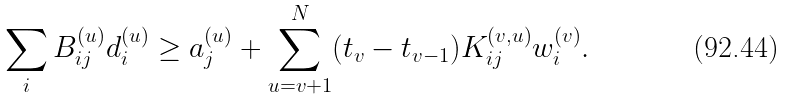<formula> <loc_0><loc_0><loc_500><loc_500>{ } \sum _ { i } B _ { i j } ^ { ( u ) } d _ { i } ^ { ( u ) } \geq a _ { j } ^ { ( u ) } + \sum _ { u = v + 1 } ^ { N } ( t _ { v } - t _ { v - 1 } ) K _ { i j } ^ { ( v , u ) } w _ { i } ^ { ( v ) } .</formula> 